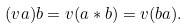<formula> <loc_0><loc_0><loc_500><loc_500>( v a ) b = v ( a * b ) = v ( b a ) .</formula> 